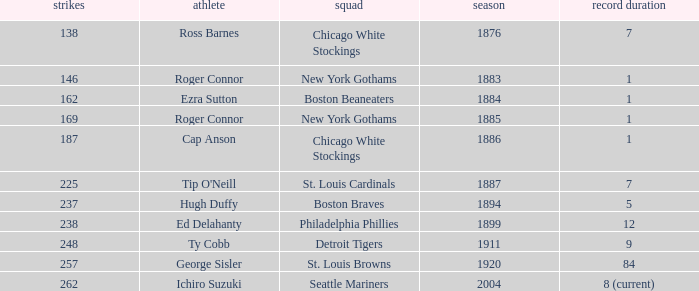Name the hits for years before 1883 138.0. 